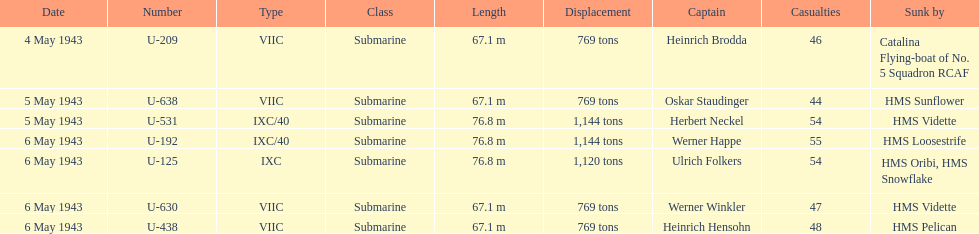What was the number of casualties on may 4 1943? 46. Parse the full table. {'header': ['Date', 'Number', 'Type', 'Class', 'Length', 'Displacement', 'Captain', 'Casualties', 'Sunk by'], 'rows': [['4 May 1943', 'U-209', 'VIIC', 'Submarine', '67.1 m', '769 tons', 'Heinrich Brodda', '46', 'Catalina Flying-boat of No. 5 Squadron RCAF'], ['5 May 1943', 'U-638', 'VIIC', 'Submarine', '67.1 m', '769 tons', 'Oskar Staudinger', '44', 'HMS Sunflower'], ['5 May 1943', 'U-531', 'IXC/40', 'Submarine', '76.8 m', '1,144 tons', 'Herbert Neckel', '54', 'HMS Vidette'], ['6 May 1943', 'U-192', 'IXC/40', 'Submarine', '76.8 m', '1,144 tons', 'Werner Happe', '55', 'HMS Loosestrife'], ['6 May 1943', 'U-125', 'IXC', 'Submarine', '76.8 m', '1,120 tons', 'Ulrich Folkers', '54', 'HMS Oribi, HMS Snowflake'], ['6 May 1943', 'U-630', 'VIIC', 'Submarine', '67.1 m', '769 tons', 'Werner Winkler', '47', 'HMS Vidette'], ['6 May 1943', 'U-438', 'VIIC', 'Submarine', '67.1 m', '769 tons', 'Heinrich Hensohn', '48', 'HMS Pelican']]} 